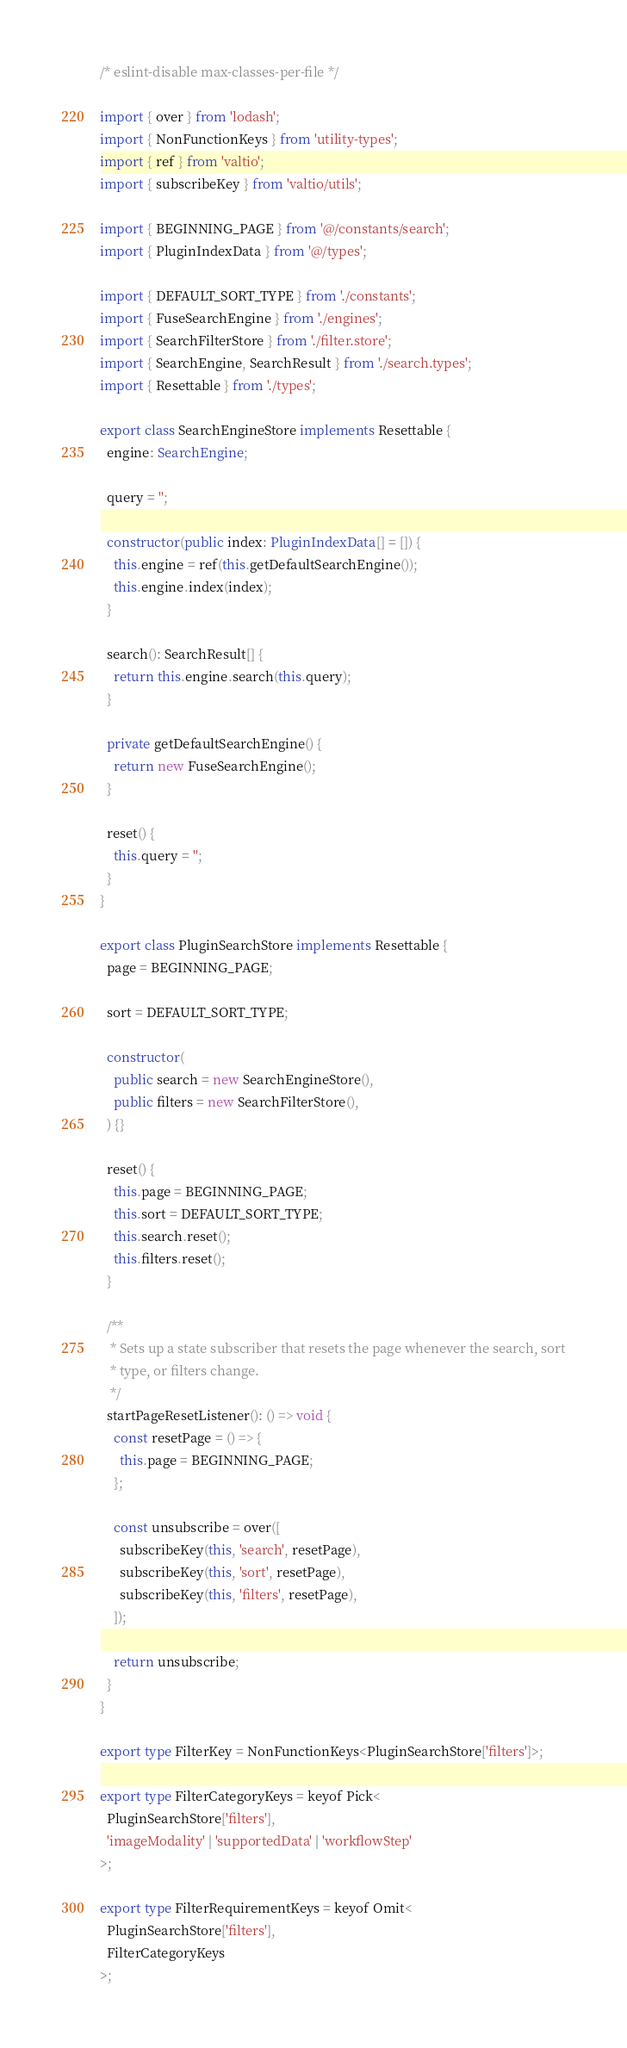<code> <loc_0><loc_0><loc_500><loc_500><_TypeScript_>/* eslint-disable max-classes-per-file */

import { over } from 'lodash';
import { NonFunctionKeys } from 'utility-types';
import { ref } from 'valtio';
import { subscribeKey } from 'valtio/utils';

import { BEGINNING_PAGE } from '@/constants/search';
import { PluginIndexData } from '@/types';

import { DEFAULT_SORT_TYPE } from './constants';
import { FuseSearchEngine } from './engines';
import { SearchFilterStore } from './filter.store';
import { SearchEngine, SearchResult } from './search.types';
import { Resettable } from './types';

export class SearchEngineStore implements Resettable {
  engine: SearchEngine;

  query = '';

  constructor(public index: PluginIndexData[] = []) {
    this.engine = ref(this.getDefaultSearchEngine());
    this.engine.index(index);
  }

  search(): SearchResult[] {
    return this.engine.search(this.query);
  }

  private getDefaultSearchEngine() {
    return new FuseSearchEngine();
  }

  reset() {
    this.query = '';
  }
}

export class PluginSearchStore implements Resettable {
  page = BEGINNING_PAGE;

  sort = DEFAULT_SORT_TYPE;

  constructor(
    public search = new SearchEngineStore(),
    public filters = new SearchFilterStore(),
  ) {}

  reset() {
    this.page = BEGINNING_PAGE;
    this.sort = DEFAULT_SORT_TYPE;
    this.search.reset();
    this.filters.reset();
  }

  /**
   * Sets up a state subscriber that resets the page whenever the search, sort
   * type, or filters change.
   */
  startPageResetListener(): () => void {
    const resetPage = () => {
      this.page = BEGINNING_PAGE;
    };

    const unsubscribe = over([
      subscribeKey(this, 'search', resetPage),
      subscribeKey(this, 'sort', resetPage),
      subscribeKey(this, 'filters', resetPage),
    ]);

    return unsubscribe;
  }
}

export type FilterKey = NonFunctionKeys<PluginSearchStore['filters']>;

export type FilterCategoryKeys = keyof Pick<
  PluginSearchStore['filters'],
  'imageModality' | 'supportedData' | 'workflowStep'
>;

export type FilterRequirementKeys = keyof Omit<
  PluginSearchStore['filters'],
  FilterCategoryKeys
>;
</code> 